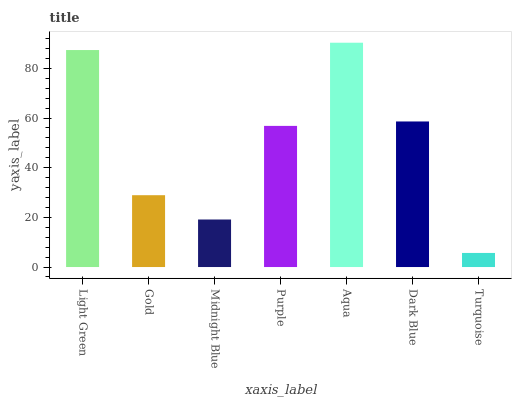Is Gold the minimum?
Answer yes or no. No. Is Gold the maximum?
Answer yes or no. No. Is Light Green greater than Gold?
Answer yes or no. Yes. Is Gold less than Light Green?
Answer yes or no. Yes. Is Gold greater than Light Green?
Answer yes or no. No. Is Light Green less than Gold?
Answer yes or no. No. Is Purple the high median?
Answer yes or no. Yes. Is Purple the low median?
Answer yes or no. Yes. Is Gold the high median?
Answer yes or no. No. Is Aqua the low median?
Answer yes or no. No. 